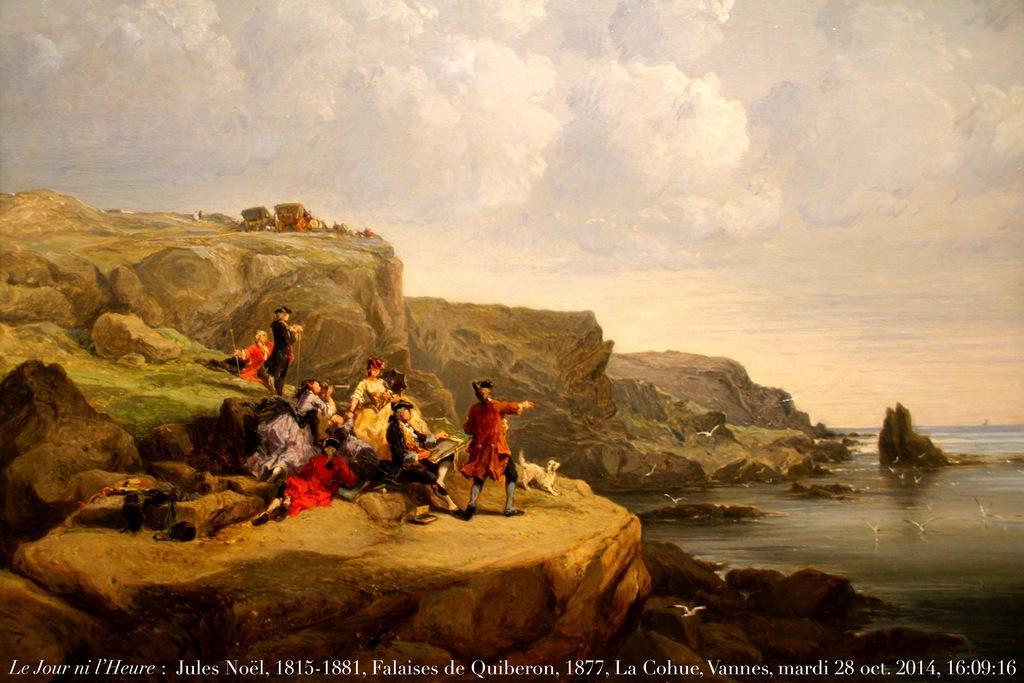Please provide a concise description of this image. This is the picture of the painting. In this picture, we see many people are sitting on the rocks. We see two men are standing. Beside them, we see a white fog. On the right side, we see water and this water might be in the lake. We see many birds are flying. In the background, we see the rocks and the hills. At the top, we see the sky. 